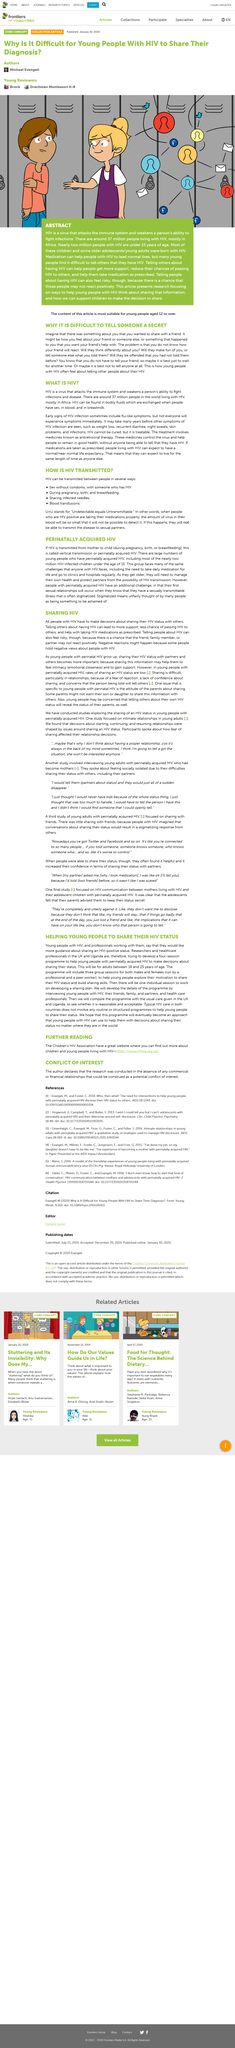Point out several critical features in this image. The four-session programme is aimed at adults between the ages of 18 and 25. Telling others about having HIV can lead to more support. HIV is a virus that causes AIDS. The programme will include a total of three group sessions. HIV, the virus that causes AIDS, can be detected in various bodily fluids, including blood, semen, vaginal fluids, and breast milk. 